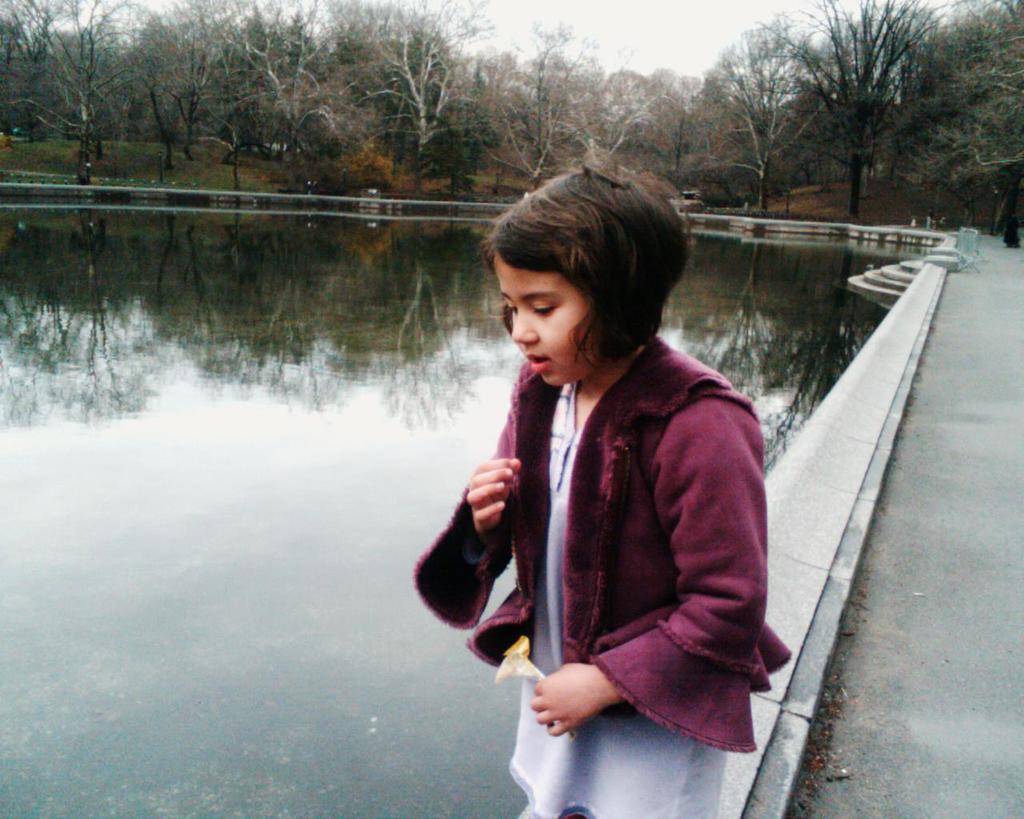How would you summarize this image in a sentence or two? In the center of the image we can see one girl standing and she is holding some object. And we can see she is wearing a jacket. In the background, we can see the sky, clouds, trees, water, staircase and a few other objects. 